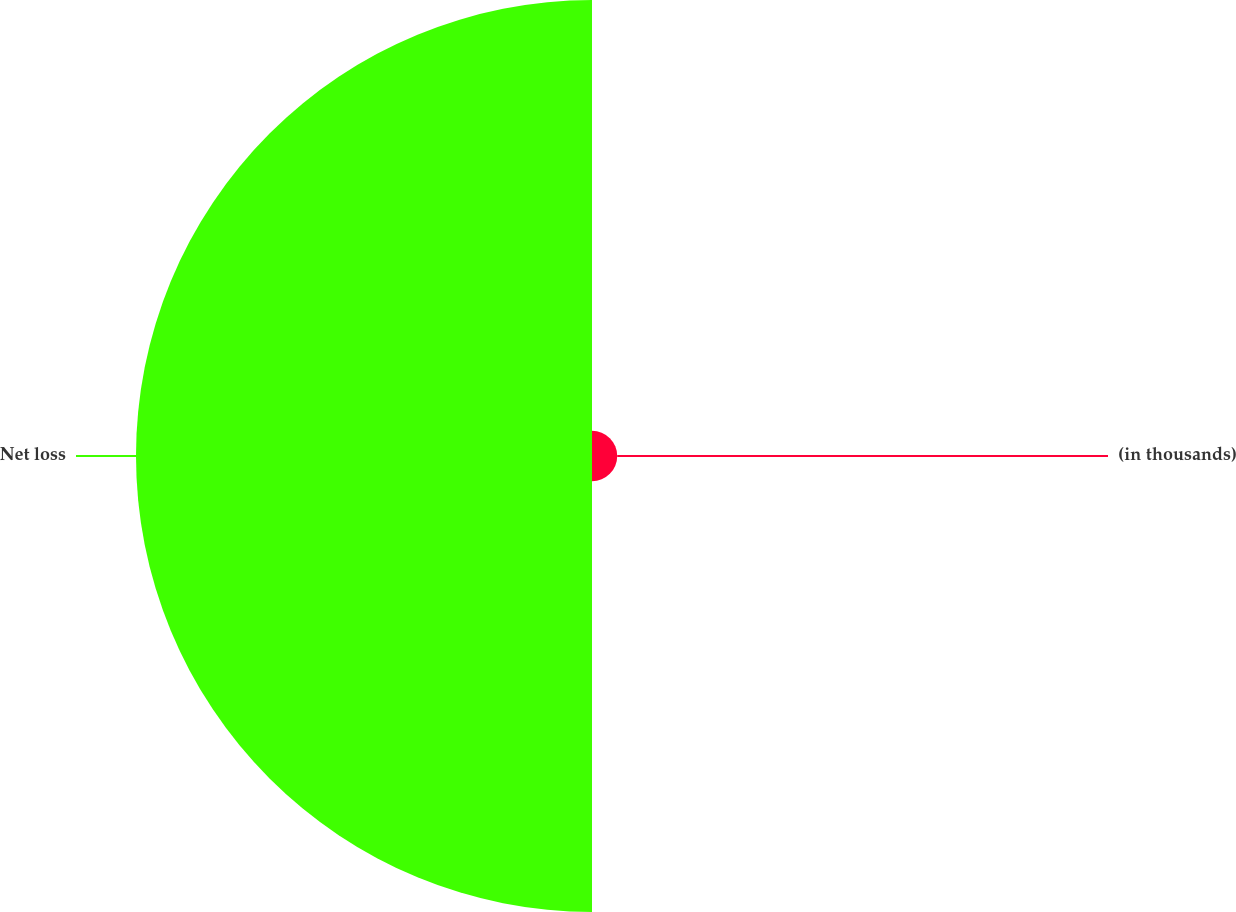Convert chart to OTSL. <chart><loc_0><loc_0><loc_500><loc_500><pie_chart><fcel>(in thousands)<fcel>Net loss<nl><fcel>5.24%<fcel>94.76%<nl></chart> 